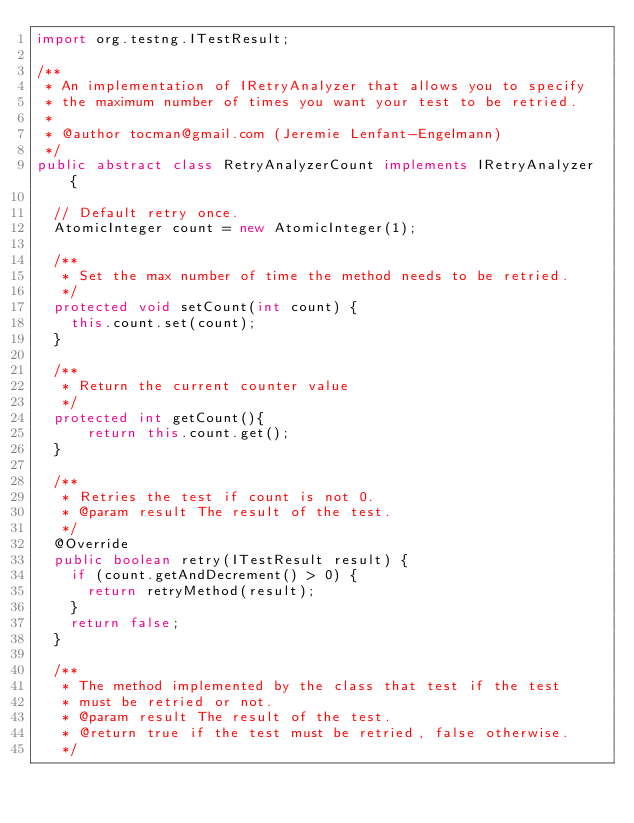Convert code to text. <code><loc_0><loc_0><loc_500><loc_500><_Java_>import org.testng.ITestResult;

/**
 * An implementation of IRetryAnalyzer that allows you to specify
 * the maximum number of times you want your test to be retried.
 *
 * @author tocman@gmail.com (Jeremie Lenfant-Engelmann)
 */
public abstract class RetryAnalyzerCount implements IRetryAnalyzer {

  // Default retry once.
  AtomicInteger count = new AtomicInteger(1);

  /**
   * Set the max number of time the method needs to be retried.
   */
  protected void setCount(int count) {
    this.count.set(count);
  }

  /**
   * Return the current counter value
   */
  protected int getCount(){
      return this.count.get();
  }

  /**
   * Retries the test if count is not 0.
   * @param result The result of the test.
   */
  @Override
  public boolean retry(ITestResult result) {
    if (count.getAndDecrement() > 0) {
      return retryMethod(result);
    }
    return false;
  }

  /**
   * The method implemented by the class that test if the test
   * must be retried or not.
   * @param result The result of the test.
   * @return true if the test must be retried, false otherwise.
   */</code> 